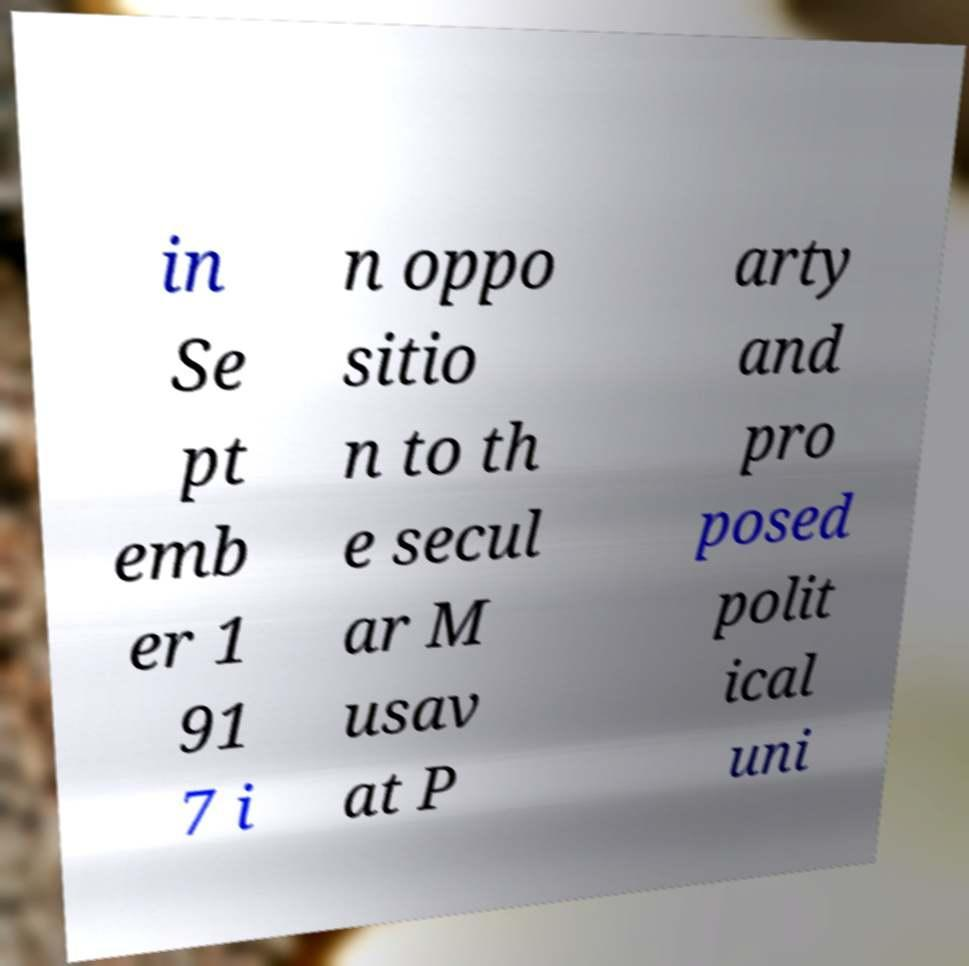There's text embedded in this image that I need extracted. Can you transcribe it verbatim? in Se pt emb er 1 91 7 i n oppo sitio n to th e secul ar M usav at P arty and pro posed polit ical uni 